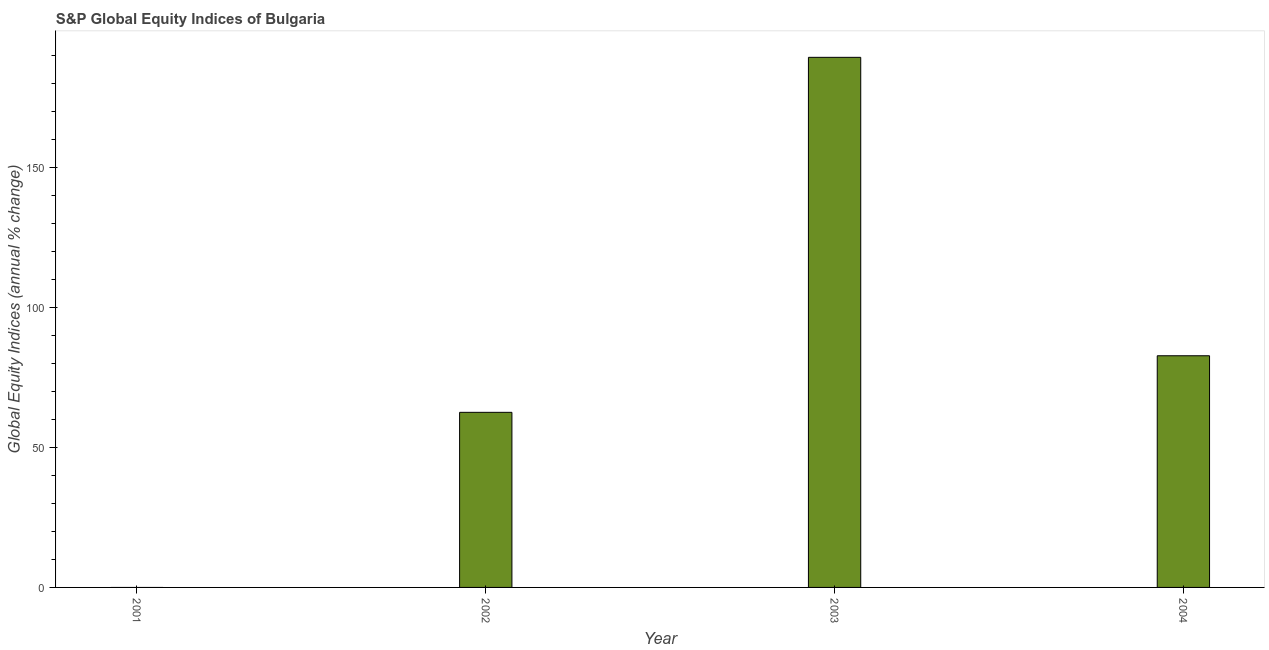What is the title of the graph?
Your answer should be very brief. S&P Global Equity Indices of Bulgaria. What is the label or title of the X-axis?
Your answer should be compact. Year. What is the label or title of the Y-axis?
Your response must be concise. Global Equity Indices (annual % change). What is the s&p global equity indices in 2003?
Provide a short and direct response. 189.23. Across all years, what is the maximum s&p global equity indices?
Offer a very short reply. 189.23. What is the sum of the s&p global equity indices?
Keep it short and to the point. 334.43. What is the difference between the s&p global equity indices in 2002 and 2003?
Offer a terse response. -126.73. What is the average s&p global equity indices per year?
Offer a very short reply. 83.61. What is the median s&p global equity indices?
Your answer should be very brief. 72.6. In how many years, is the s&p global equity indices greater than 110 %?
Keep it short and to the point. 1. What is the ratio of the s&p global equity indices in 2003 to that in 2004?
Your response must be concise. 2.29. Is the difference between the s&p global equity indices in 2002 and 2004 greater than the difference between any two years?
Your answer should be compact. No. What is the difference between the highest and the second highest s&p global equity indices?
Keep it short and to the point. 106.53. Is the sum of the s&p global equity indices in 2003 and 2004 greater than the maximum s&p global equity indices across all years?
Make the answer very short. Yes. What is the difference between the highest and the lowest s&p global equity indices?
Your answer should be compact. 189.23. In how many years, is the s&p global equity indices greater than the average s&p global equity indices taken over all years?
Provide a succinct answer. 1. Are all the bars in the graph horizontal?
Your response must be concise. No. What is the difference between two consecutive major ticks on the Y-axis?
Offer a terse response. 50. What is the Global Equity Indices (annual % change) of 2001?
Provide a succinct answer. 0. What is the Global Equity Indices (annual % change) of 2002?
Provide a short and direct response. 62.5. What is the Global Equity Indices (annual % change) in 2003?
Give a very brief answer. 189.23. What is the Global Equity Indices (annual % change) of 2004?
Provide a short and direct response. 82.7. What is the difference between the Global Equity Indices (annual % change) in 2002 and 2003?
Offer a terse response. -126.73. What is the difference between the Global Equity Indices (annual % change) in 2002 and 2004?
Provide a short and direct response. -20.2. What is the difference between the Global Equity Indices (annual % change) in 2003 and 2004?
Give a very brief answer. 106.53. What is the ratio of the Global Equity Indices (annual % change) in 2002 to that in 2003?
Offer a very short reply. 0.33. What is the ratio of the Global Equity Indices (annual % change) in 2002 to that in 2004?
Offer a very short reply. 0.76. What is the ratio of the Global Equity Indices (annual % change) in 2003 to that in 2004?
Make the answer very short. 2.29. 